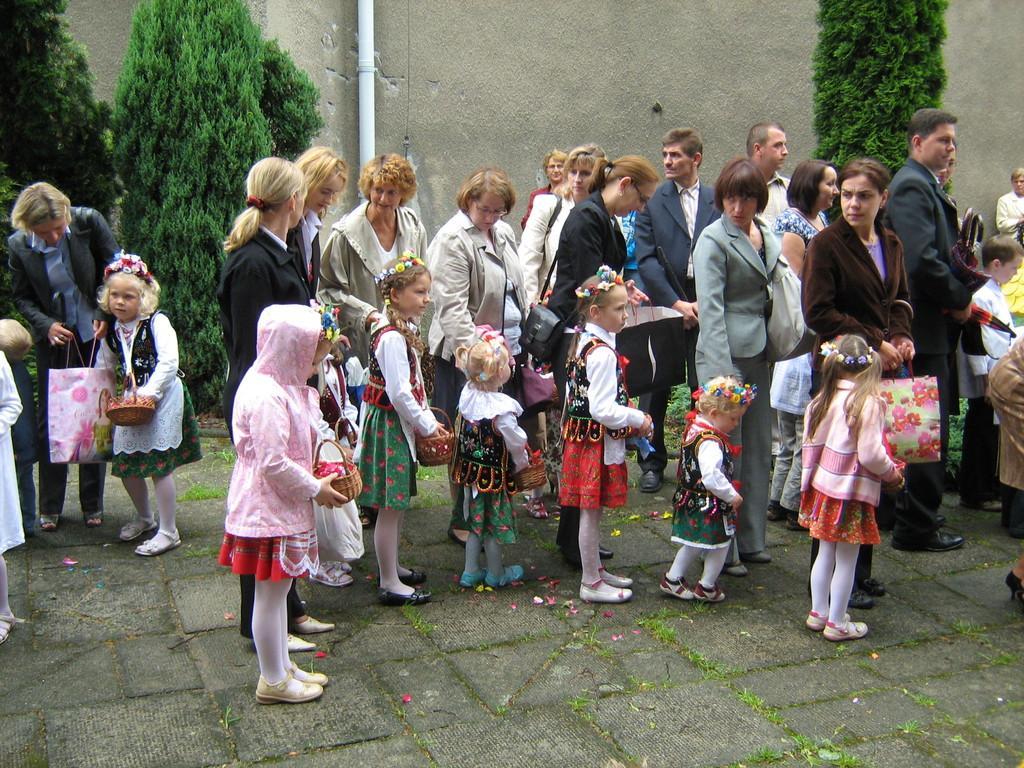Could you give a brief overview of what you see in this image? This image consists of many persons standing on the ground. In the front, there are children. In the background, there are trees along with a wall. And there is a pipe fixed to the wall. 